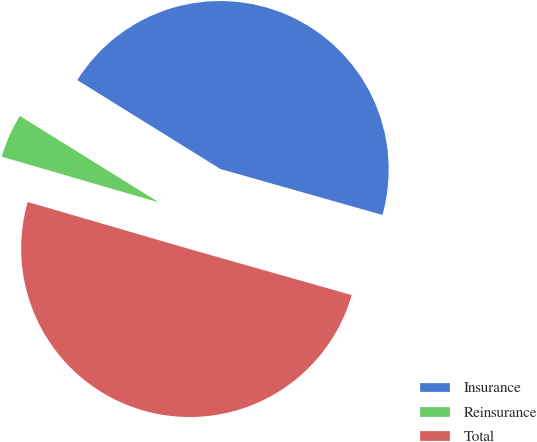Convert chart to OTSL. <chart><loc_0><loc_0><loc_500><loc_500><pie_chart><fcel>Insurance<fcel>Reinsurance<fcel>Total<nl><fcel>45.55%<fcel>4.34%<fcel>50.11%<nl></chart> 